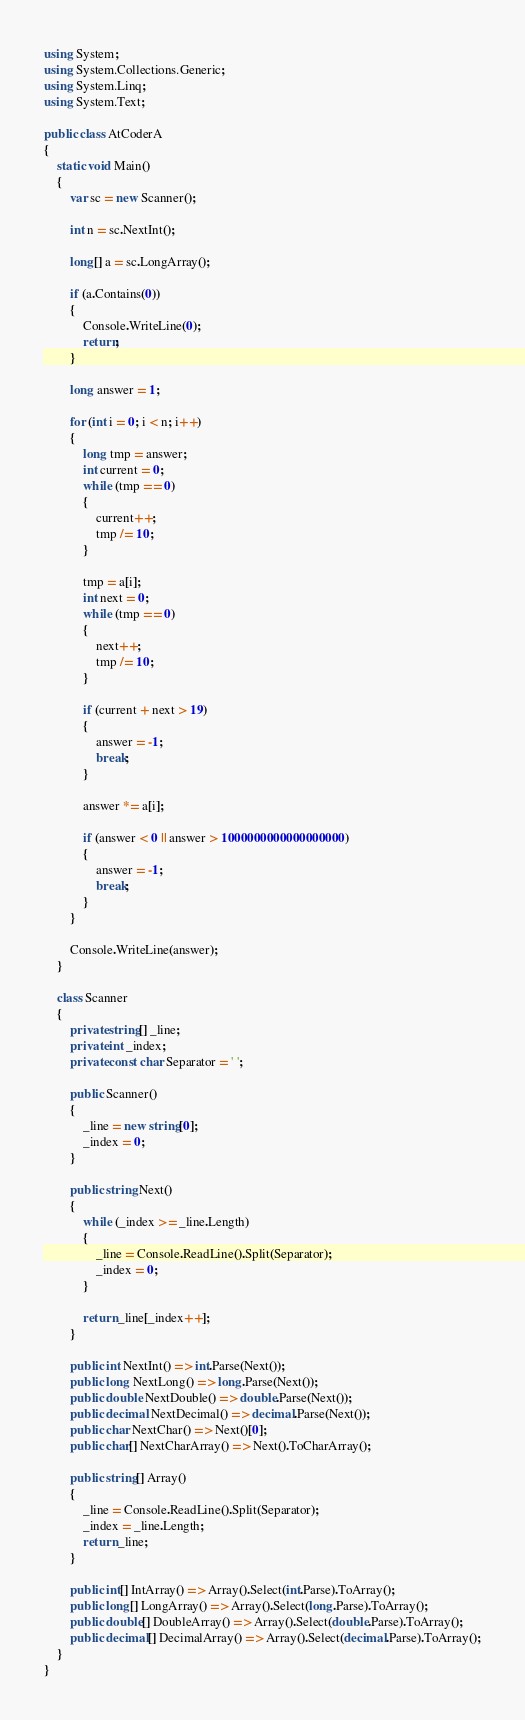<code> <loc_0><loc_0><loc_500><loc_500><_C#_>using System;
using System.Collections.Generic;
using System.Linq;
using System.Text;

public class AtCoderA
{
    static void Main()
    {
        var sc = new Scanner();

        int n = sc.NextInt();

        long[] a = sc.LongArray();

        if (a.Contains(0))
        {
            Console.WriteLine(0);
            return;
        }

        long answer = 1;

        for (int i = 0; i < n; i++)
        {
            long tmp = answer;
            int current = 0;
            while (tmp == 0)
            {
                current++;
                tmp /= 10;
            }

            tmp = a[i];
            int next = 0;
            while (tmp == 0)
            {
                next++;
                tmp /= 10;
            }

            if (current + next > 19)
            {
                answer = -1;
                break;
            }

            answer *= a[i];

            if (answer < 0 || answer > 1000000000000000000)
            {
                answer = -1;
                break;
            }
        }

        Console.WriteLine(answer);
    }

    class Scanner
    {
        private string[] _line;
        private int _index;
        private const char Separator = ' ';

        public Scanner()
        {
            _line = new string[0];
            _index = 0;
        }

        public string Next()
        {
            while (_index >= _line.Length)
            {
                _line = Console.ReadLine().Split(Separator);
                _index = 0;
            }

            return _line[_index++];
        }

        public int NextInt() => int.Parse(Next());
        public long NextLong() => long.Parse(Next());
        public double NextDouble() => double.Parse(Next());
        public decimal NextDecimal() => decimal.Parse(Next());
        public char NextChar() => Next()[0];
        public char[] NextCharArray() => Next().ToCharArray();

        public string[] Array()
        {
            _line = Console.ReadLine().Split(Separator);
            _index = _line.Length;
            return _line;
        }

        public int[] IntArray() => Array().Select(int.Parse).ToArray();
        public long[] LongArray() => Array().Select(long.Parse).ToArray();
        public double[] DoubleArray() => Array().Select(double.Parse).ToArray();
        public decimal[] DecimalArray() => Array().Select(decimal.Parse).ToArray();
    }
}</code> 